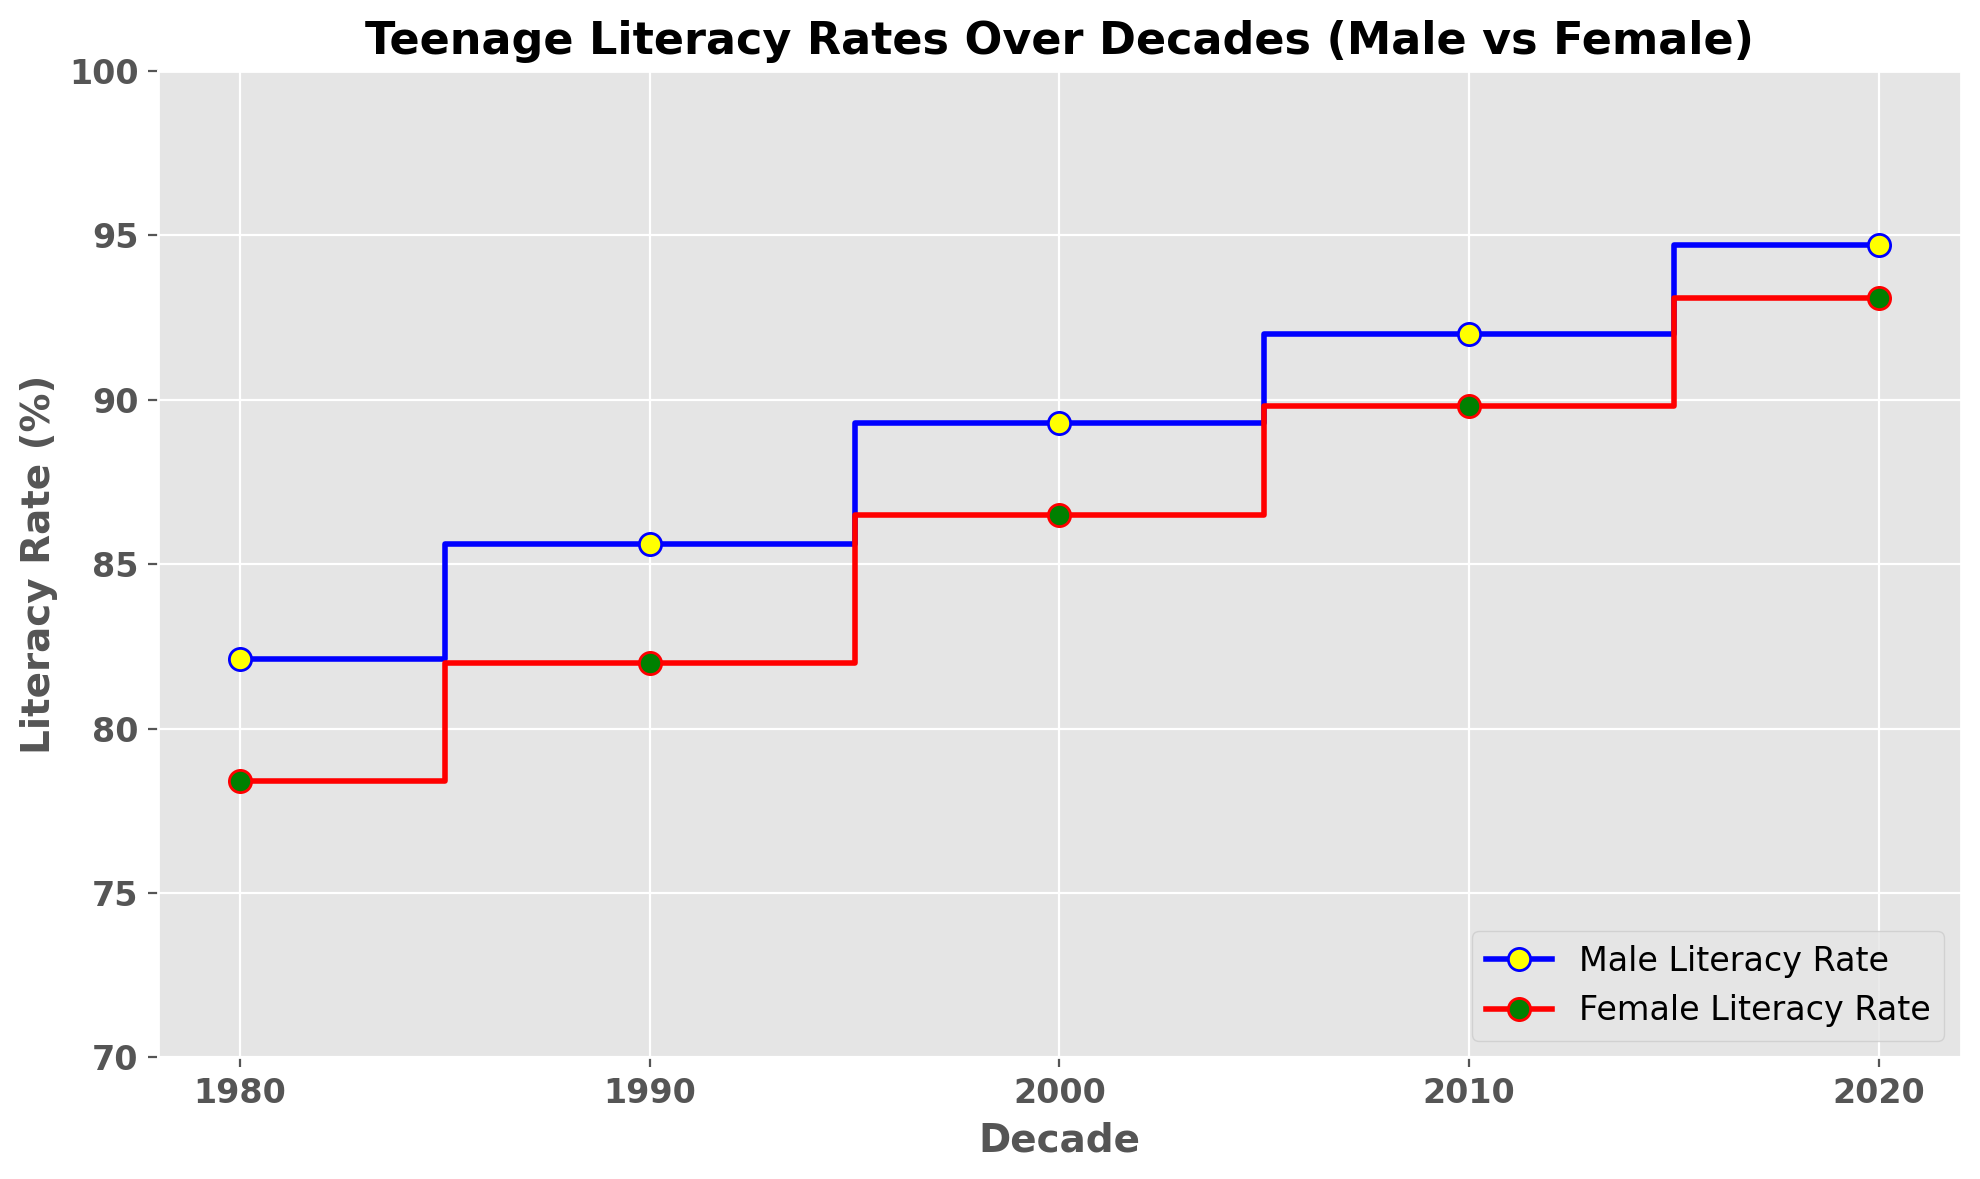What is the difference in male literacy rates between 1980 and 2020? The male literacy rate in 1980 is 82.1% and in 2020 it is 94.7%. The difference is calculated as 94.7% - 82.1% = 12.6%.
Answer: 12.6% By how many percentage points did female literacy rates increase from 1990 to 2020? The female literacy rate in 1990 is 82.0% and in 2020 it is 93.1%. The increase is calculated as 93.1% - 82.0% = 11.1 percentage points.
Answer: 11.1 Which decade saw the highest increase in female literacy rates? By examining the plot, we compare the rate increases between consecutive decades. The largest increase is from 1990 to 2000 (82.0% to 86.5%), which is 4.5%.
Answer: 1990 to 2000 In 2010, was the male literacy rate higher than the female literacy rate? In 2010, the male literacy rate is 92.0% and the female literacy rate is 89.8%. 92.0% is higher than 89.8%.
Answer: Yes What color represents the female literacy rate on the plot? The plot uses color to differentiate gender literacy rates. The female literacy rate is marked in red.
Answer: Red By how many percentage points did the male literacy rate increase from 1980 to 1990? The male literacy rate in 1980 is 82.1% and in 1990 it is 85.6%. The increase is calculated as 85.6% - 82.1% = 3.5 percentage points.
Answer: 3.5 Which gender had a higher literacy rate in 1980? In 1980, the male literacy rate is 82.1% and the female literacy rate is 78.4%. 82.1% is higher than 78.4%.
Answer: Male On average, which literacy rate increased more per decade from 1980 to 2020, male or female? Calculate the total increase for each gender from 1980 to 2020 (Male: 94.7% - 82.1% = 12.6%; Female: 93.1% - 78.4% = 14.7%), then divide by the number of decades (12.6% / 4 and 14.7% / 4). The average increase per decade for males is 3.15% and for females 3.675%. The female literacy rate had a higher average increase per decade.
Answer: Female Between which two consecutive decades was the smallest increase in male literacy rates observed? Comparing the increases across decades: 
1980-1990: 3.5%, 
1990-2000: 3.7%, 
2000-2010: 2.7%, 
2010-2020: 2.7%. 
The smallest increase is 2.7% between 2000-2010 and 2010-2020.
Answer: 2000-2010 and 2010-2020 